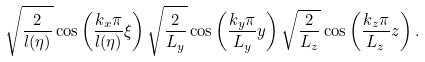<formula> <loc_0><loc_0><loc_500><loc_500>\sqrt { \frac { 2 } { l ( \eta ) } } \cos \left ( \frac { k _ { x } \pi } { l ( \eta ) } \xi \right ) \sqrt { \frac { 2 } { L _ { y } } } \cos \left ( \frac { k _ { y } \pi } { L _ { y } } y \right ) \sqrt { \frac { 2 } { L _ { z } } } \cos \left ( \frac { k _ { z } \pi } { L _ { z } } z \right ) .</formula> 